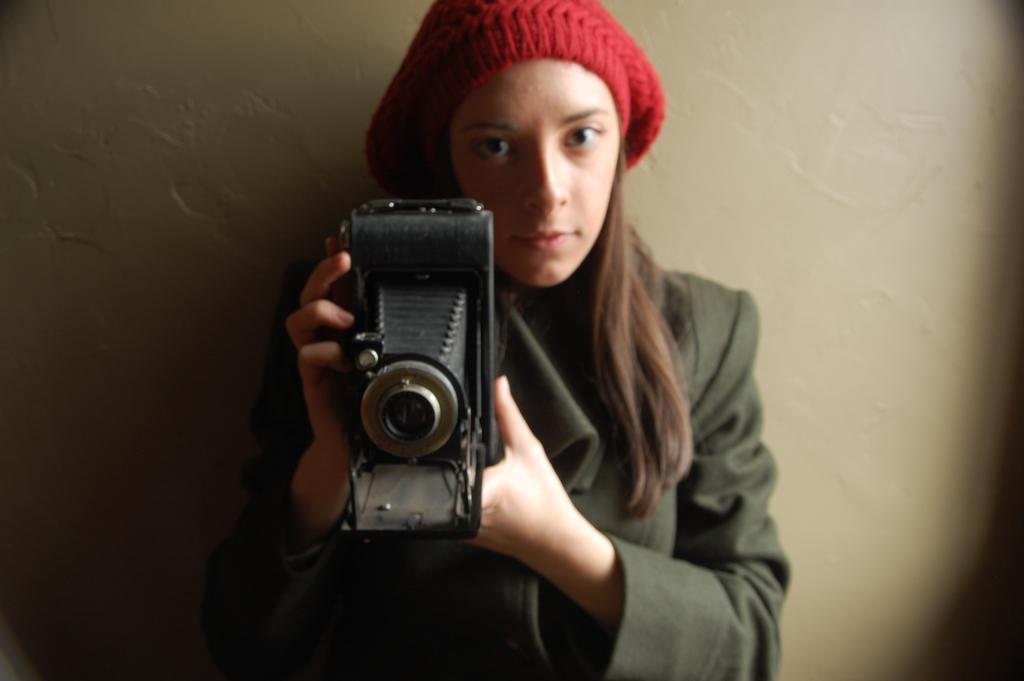Can you describe this image briefly? In this image I can see a person holding a camera. In the background it looks like a wall. 